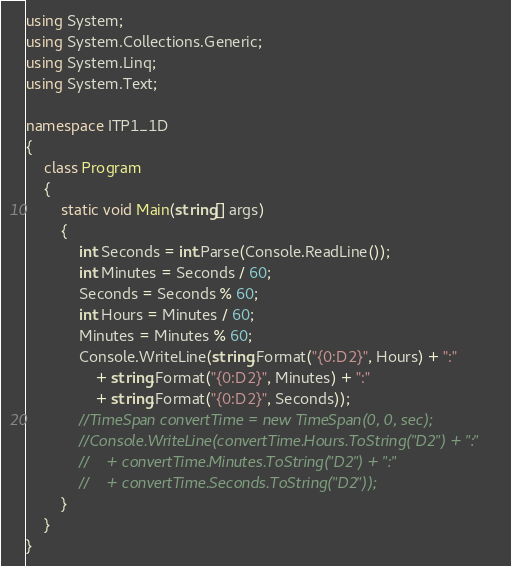<code> <loc_0><loc_0><loc_500><loc_500><_C#_>using System;
using System.Collections.Generic;
using System.Linq;
using System.Text;

namespace ITP1_1D
{
    class Program
    {
        static void Main(string[] args)
        {
            int Seconds = int.Parse(Console.ReadLine());
            int Minutes = Seconds / 60;
            Seconds = Seconds % 60;
            int Hours = Minutes / 60;
            Minutes = Minutes % 60;
            Console.WriteLine(string.Format("{0:D2}", Hours) + ":"
                + string.Format("{0:D2}", Minutes) + ":"
                + string.Format("{0:D2}", Seconds));
            //TimeSpan convertTime = new TimeSpan(0, 0, sec);
            //Console.WriteLine(convertTime.Hours.ToString("D2") + ":" 
            //    + convertTime.Minutes.ToString("D2") + ":" 
            //    + convertTime.Seconds.ToString("D2")); 
        }
    }
}</code> 